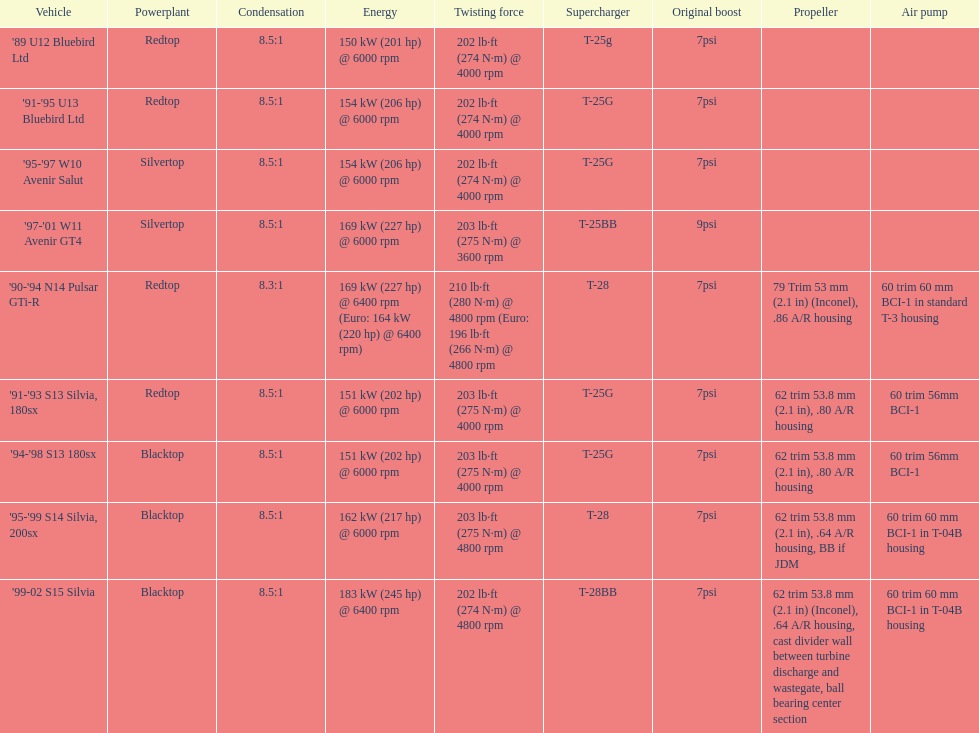How many models used the redtop engine? 4. 